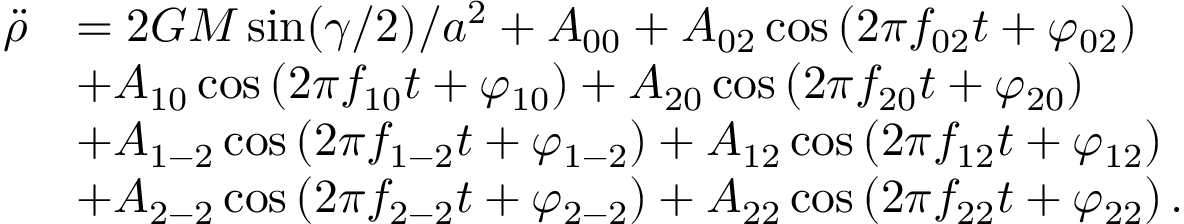<formula> <loc_0><loc_0><loc_500><loc_500>\begin{array} { r l } { \ddot { \rho } } & { = 2 G M \sin ( \gamma / 2 ) / a ^ { 2 } + A _ { 0 0 } + A _ { 0 2 } \cos \left ( 2 \pi f _ { 0 2 } t + \varphi _ { 0 2 } \right ) } \\ & { + A _ { 1 0 } \cos \left ( 2 \pi f _ { 1 0 } t + \varphi _ { 1 0 } \right ) + A _ { 2 0 } \cos \left ( 2 \pi f _ { 2 0 } t + \varphi _ { 2 0 } \right ) } \\ & { + A _ { 1 - 2 } \cos \left ( 2 \pi f _ { 1 - 2 } t + \varphi _ { 1 - 2 } \right ) + A _ { 1 2 } \cos \left ( 2 \pi f _ { 1 2 } t + \varphi _ { 1 2 } \right ) } \\ & { + A _ { 2 - 2 } \cos \left ( 2 \pi f _ { 2 - 2 } t + \varphi _ { 2 - 2 } \right ) + A _ { 2 2 } \cos \left ( 2 \pi f _ { 2 2 } t + \varphi _ { 2 2 } \right ) . } \end{array}</formula> 